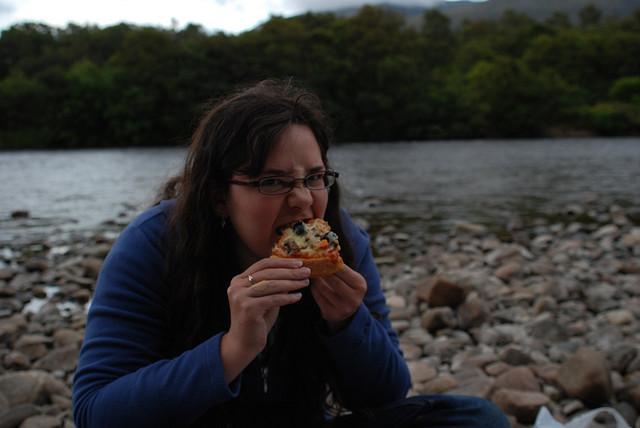What is the person holding?
Quick response, please. Pizza. Male or female?
Give a very brief answer. Female. What is this person eating?
Answer briefly. Pizza. What toppings are on the pizza?
Short answer required. Olives. How tacky is this person?
Give a very brief answer. Not at all. What is this lady eating?
Concise answer only. Pizza. Does she have any jewelry on?
Write a very short answer. Yes. Are the glasses tinted?
Short answer required. No. What is the weather?
Keep it brief. Overcast. What is the man eating?
Answer briefly. Pizza. Is the lady wearing glasses?
Quick response, please. Yes. 